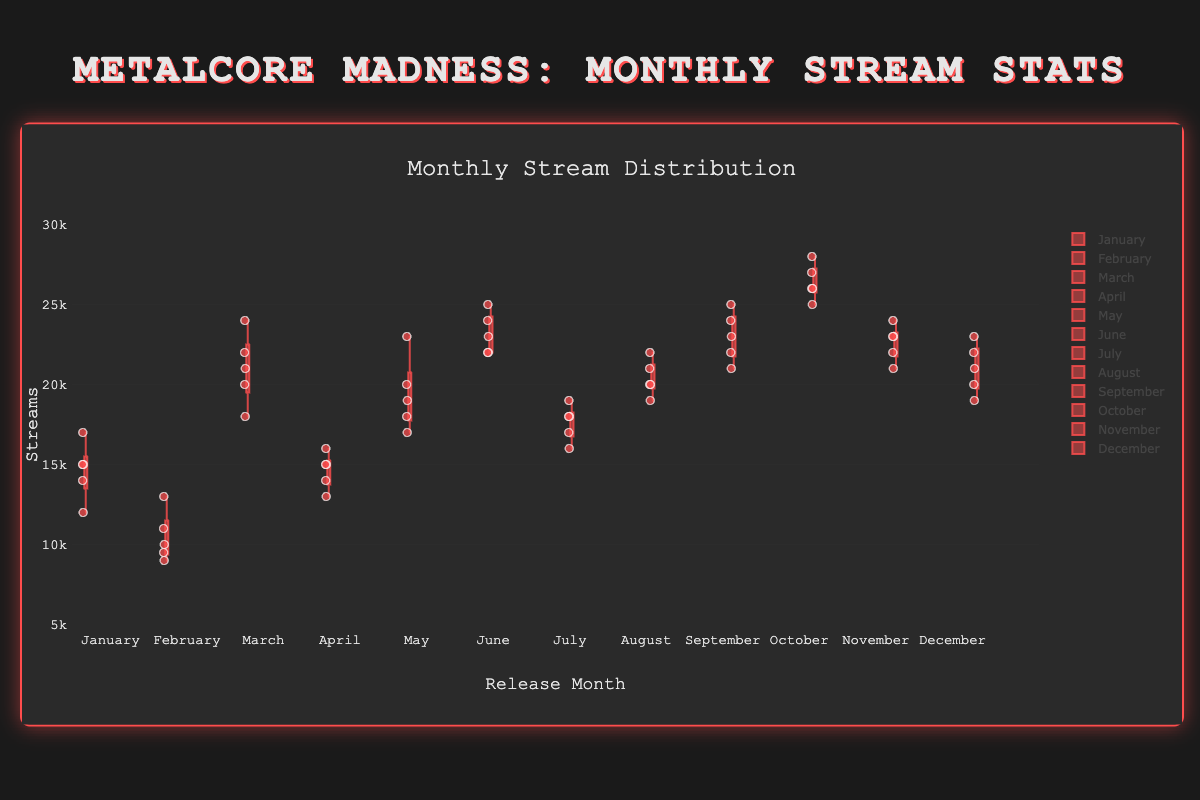Which month has the highest median stream count? The median is the central value of the dataset in each month. By visually inspecting the box plots, you can find the vertical line within the box that represents the median. October has the highest median compared to other months.
Answer: October How many months have a median stream count below 20,000? Inspect the position of the median line for each month's box plot. Count how many months have their median below the value of 20,000 situated on the y-axis.
Answer: 5 Which month shows the widest interquartile range (IQR)? The IQR is the difference between the third quartile (Q3) and the first quartile (Q1). Identify the months with the largest height in their respective boxes. By visual inspection, June appears to have the widest IQR.
Answer: June Is November more consistent in stream counts than September? Consistency can be observed in the spread of the box plot. A narrow box and shorter whiskers indicate more consistency. Comparing November and September, November’s box plot is narrower and has shorter whiskers.
Answer: Yes Compare the median stream counts between February and July. Which is higher? Look at the median lines inside the boxes for February and July. The median line for February is lower on the y-axis than July's.
Answer: July Which month has the highest outlier stream count? Outliers are marked as points outside the whiskers. The month with the highest outlier visible on the y-axis scale is October.
Answer: October How does the consistency of stream counts in May compare to December? By comparing the widths of the boxes and lengths of the whiskers, May shows a narrower box and shorter whiskers compared to December, indicating more consistency.
Answer: More consistent What is the median stream count in June? The median is represented by the line inside the box in June’s box plot, which is at 23000 streams.
Answer: 23000 Is there any month with no outliers depicted? Outliers are points outside the whisker lines. Inspect each month's box plot to see if they have no points outside the whiskers. April does not show any outliers.
Answer: April 